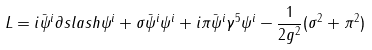Convert formula to latex. <formula><loc_0><loc_0><loc_500><loc_500>L = i \bar { \psi } ^ { i } \partial s l a s h \psi ^ { i } + \sigma \bar { \psi } ^ { i } \psi ^ { i } + i \pi \bar { \psi } ^ { i } \gamma ^ { 5 } \psi ^ { i } - \frac { 1 } { 2 g ^ { 2 } } ( \sigma ^ { 2 } + \pi ^ { 2 } )</formula> 